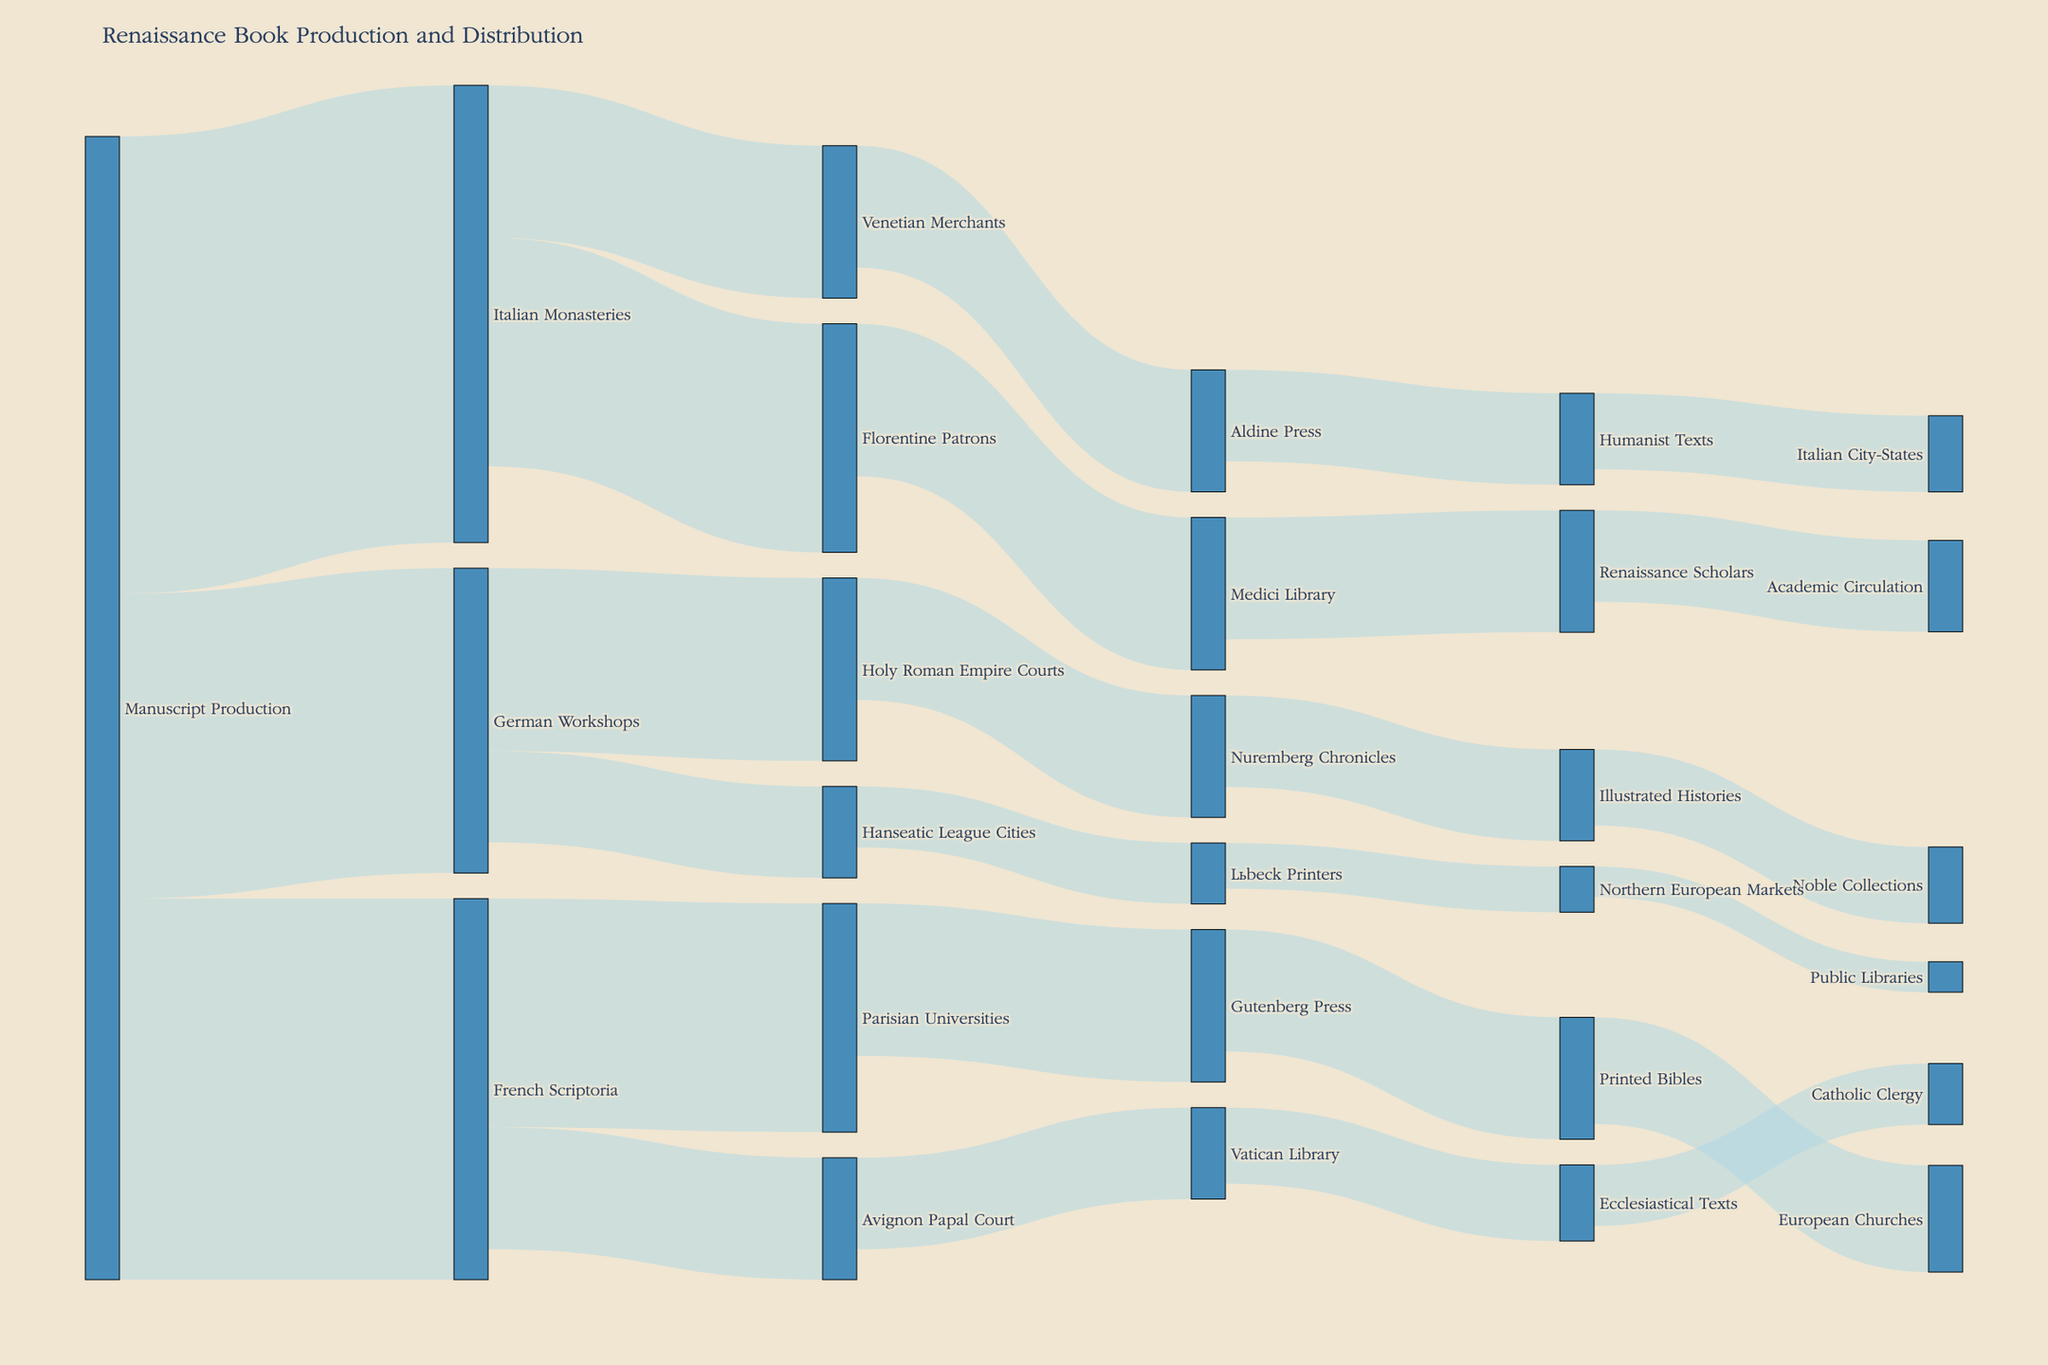How many sources are involved in the initial production of manuscripts? The Sankey diagram shows "Manuscript Production" leading to "Italian Monasteries," "French Scriptoria," and "German Workshops." Each of these represents a source. Count them to get the total number.
Answer: 3 Which entity receives the highest number of manuscripts from "French Scriptoria"? From the Sankey diagram, "French Scriptoria" distributes manuscripts to "Parisian Universities" and "Avignon Papal Court." The values are 150 and 80 respectively.
Answer: Parisian Universities How many manuscripts in total are produced by the "German Workshops"? Summing all the values from the "German Workshops" flowing to different targets: 120 (Holy Roman Empire Courts) + 60 (Hanseatic League Cities).
Answer: 180 What is the total quantity of manuscripts initially produced across all sources? The values from "Manuscript Production" leading to "Italian Monasteries" (300), "French Scriptoria" (250), and "German Workshops" (200) are added up. 300 + 250 + 200
Answer: 750 Compared to "Gutenberg Press," how many more manuscripts are distributed to "European Churches" from "Printed Bibles"? "Printed Bibles" to "European Churches" has a flow of 70 while "Parisian Universities" to "Gutenberg Press" has 100 manuscripts. 100 - 70
Answer: 30 What's the total number of entities receiving manuscripts from "Italian Monasteries"? "Italian Monasteries" distributes manuscripts to "Florentine Patrons" and "Venetian Merchants." Counting these entities.
Answer: 2 Which node acts as an intermediary receiving manuscripts from more than one source? The Sankey diagram shows "Parisian Universities" receiving from "French Scriptoria" and later sending to "Gutenberg Press."
Answer: Parisian Universities How many manuscripts are received by "Renaissance Scholars"? From the diagram, "Renaissance Scholars" receives 80 manuscripts from "Medici Library."
Answer: 80 What is the final destination of manuscripts flowing through the "Nuremberg Chronicles"? The Sankey diagram shows "Nuremberg Chronicles" leading to "Illustrated Histories," which is the final distribution.
Answer: Illustrated Histories Which organization distributes the same number of manuscripts to different targets? "Italian Monasteries" distributes to "Florentine Patrons" (150) and "Venetian Merchants" (100). "Venetian Merchants" passes an equal number (80) to "Aldine Press."
Answer: Venetian Merchants 